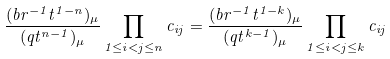<formula> <loc_0><loc_0><loc_500><loc_500>\frac { ( b r ^ { - 1 } t ^ { 1 - n } ) _ { \mu } } { ( q t ^ { n - 1 } ) _ { \mu } } \prod _ { 1 \leq i < j \leq n } c _ { i j } = \frac { ( b r ^ { - 1 } t ^ { 1 - k } ) _ { \mu } } { ( q t ^ { k - 1 } ) _ { \mu } } \prod _ { 1 \leq i < j \leq k } c _ { i j }</formula> 